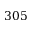<formula> <loc_0><loc_0><loc_500><loc_500>3 0 5</formula> 